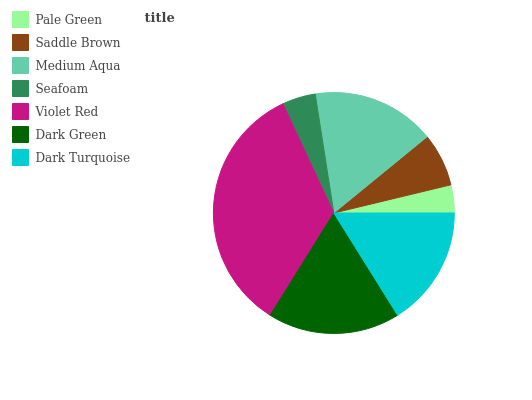Is Pale Green the minimum?
Answer yes or no. Yes. Is Violet Red the maximum?
Answer yes or no. Yes. Is Saddle Brown the minimum?
Answer yes or no. No. Is Saddle Brown the maximum?
Answer yes or no. No. Is Saddle Brown greater than Pale Green?
Answer yes or no. Yes. Is Pale Green less than Saddle Brown?
Answer yes or no. Yes. Is Pale Green greater than Saddle Brown?
Answer yes or no. No. Is Saddle Brown less than Pale Green?
Answer yes or no. No. Is Dark Turquoise the high median?
Answer yes or no. Yes. Is Dark Turquoise the low median?
Answer yes or no. Yes. Is Dark Green the high median?
Answer yes or no. No. Is Seafoam the low median?
Answer yes or no. No. 